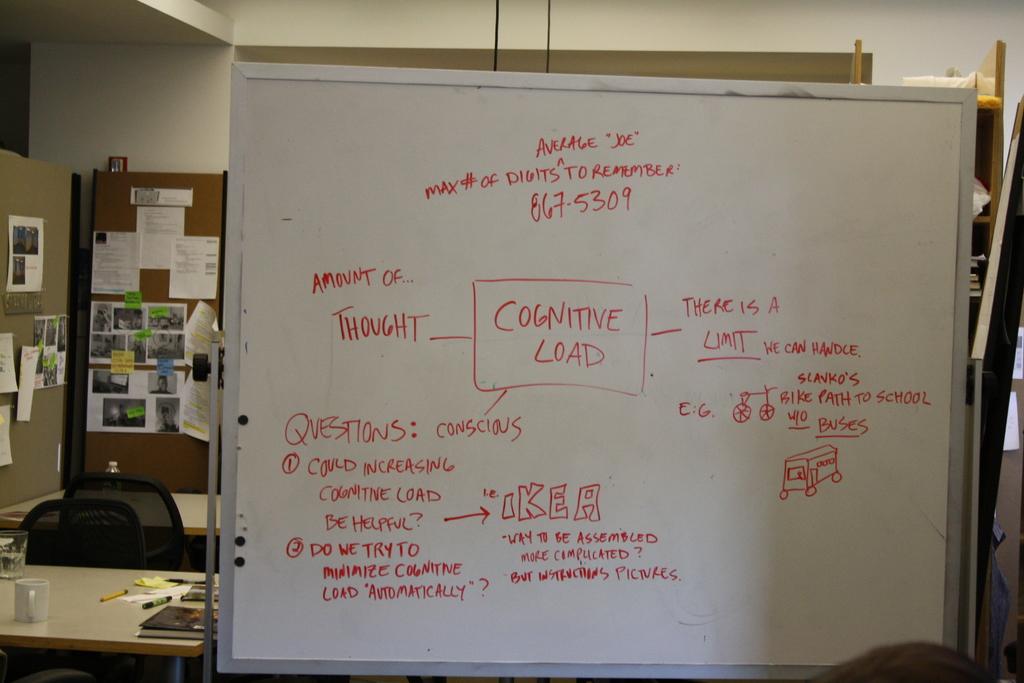Is there a limit to cognitive load?
Your response must be concise. Yes. What is the phone number on the whiteboard?
Offer a terse response. 867-5309. 